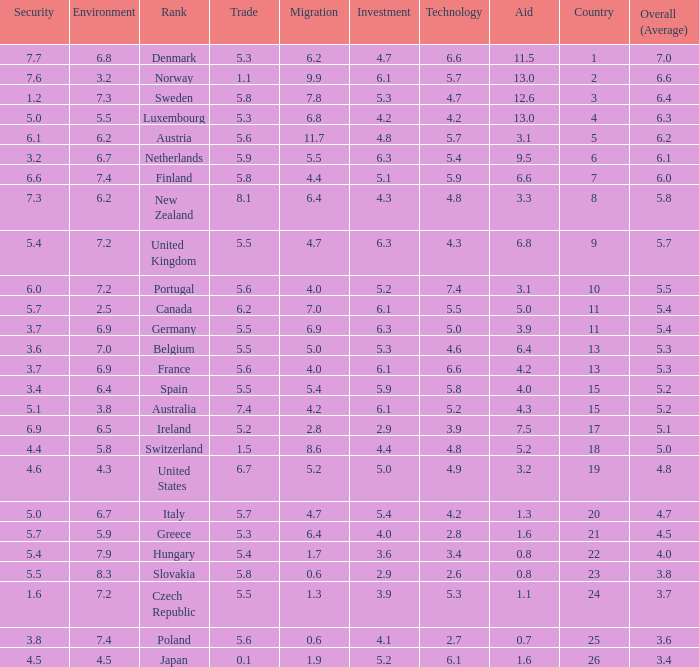What country has a 5.5 mark for security? Slovakia. 